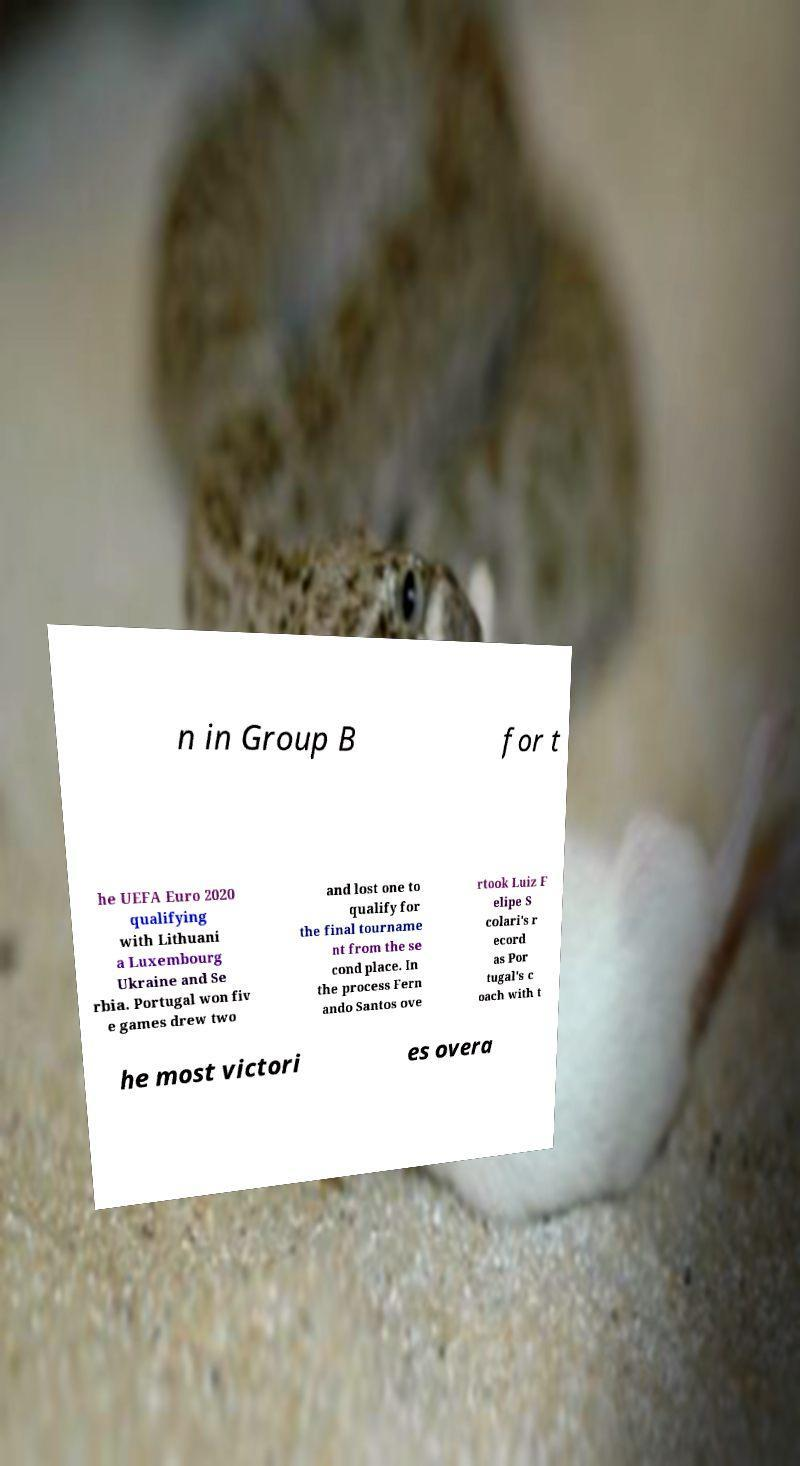Can you read and provide the text displayed in the image?This photo seems to have some interesting text. Can you extract and type it out for me? n in Group B for t he UEFA Euro 2020 qualifying with Lithuani a Luxembourg Ukraine and Se rbia. Portugal won fiv e games drew two and lost one to qualify for the final tourname nt from the se cond place. In the process Fern ando Santos ove rtook Luiz F elipe S colari's r ecord as Por tugal's c oach with t he most victori es overa 